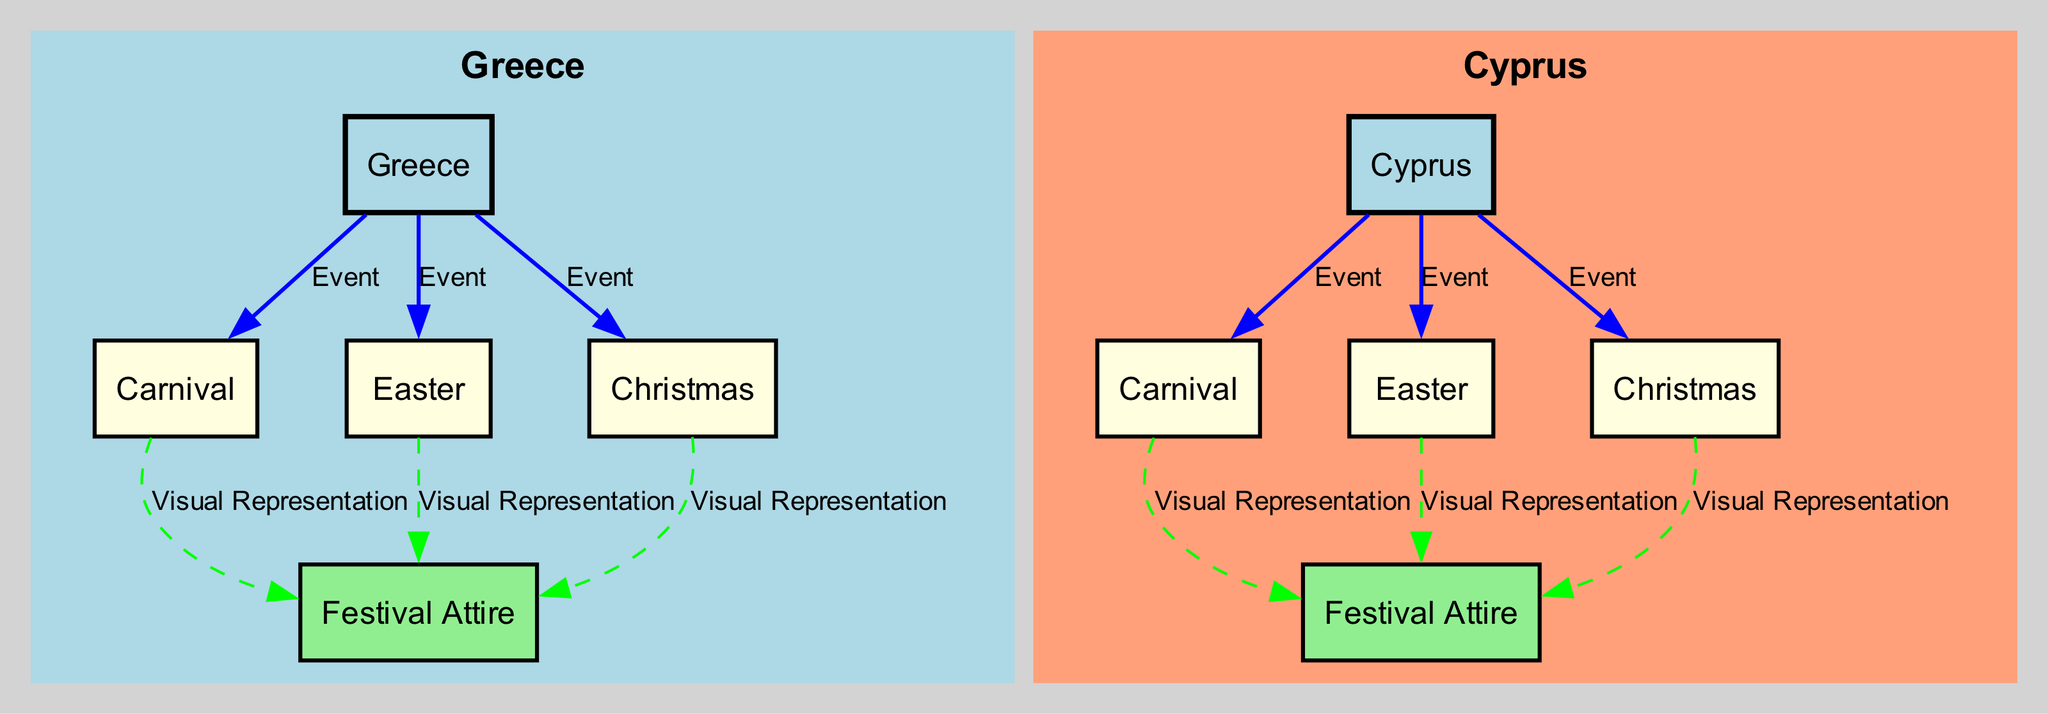What traditional festival is celebrated in both Greece and Cyprus around the same time? Upon reviewing the diagram, we observe that both Greece and Cyprus have "Carnival" as a common festival event, which takes place in a similar timeframe.
Answer: Carnival How many festival events are there in total for Greece? The diagram shows three festival events linked to Greece: "Carnival," "Easter," and "Christmas." Therefore, adding these together gives a total of three events.
Answer: 3 Which festival in Greece has a corresponding visual representation? The diagram indicates that "Carnival," "Easter," and "Christmas" in Greece all connect to "Festival Attire," making it clear that all these festivals have visual representations associated with them.
Answer: Carnival, Easter, Christmas How are the festivals categorized in the diagram? The diagram uses three categories: "Festival Attire" for Greece and "Festival Attire" for Cyprus, both visual representations. The events are connected to these categories, confirming their classification.
Answer: Festival Attire What is the color of the nodes representing Cyprus? The diagram features nodes representing Cyprus in a light salmon color, which is easily identifiable throughout the visual structure.
Answer: Light salmon 